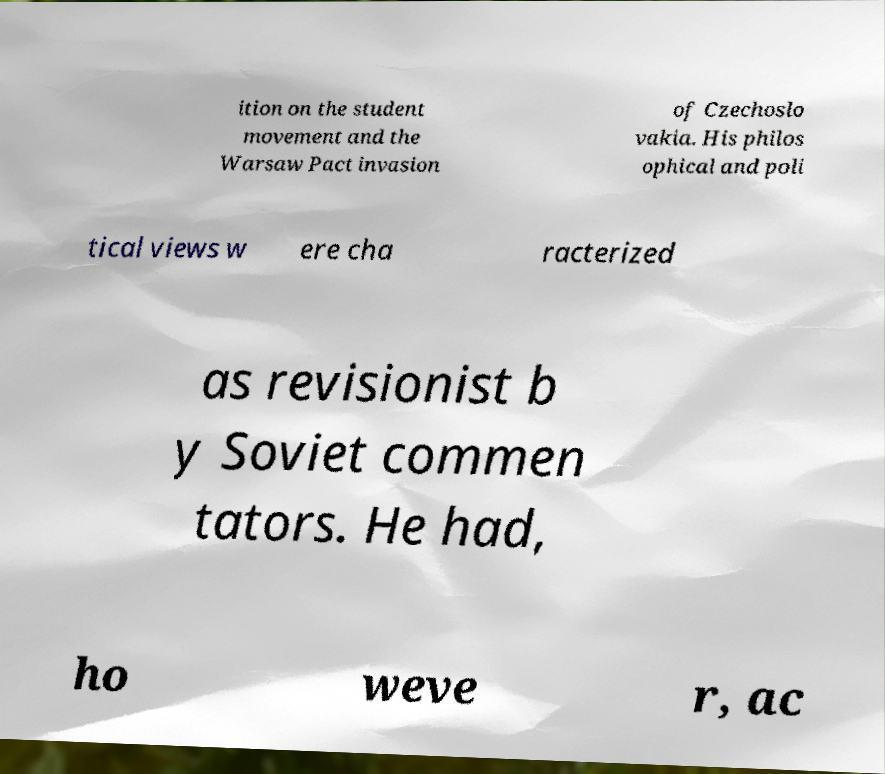Can you accurately transcribe the text from the provided image for me? ition on the student movement and the Warsaw Pact invasion of Czechoslo vakia. His philos ophical and poli tical views w ere cha racterized as revisionist b y Soviet commen tators. He had, ho weve r, ac 